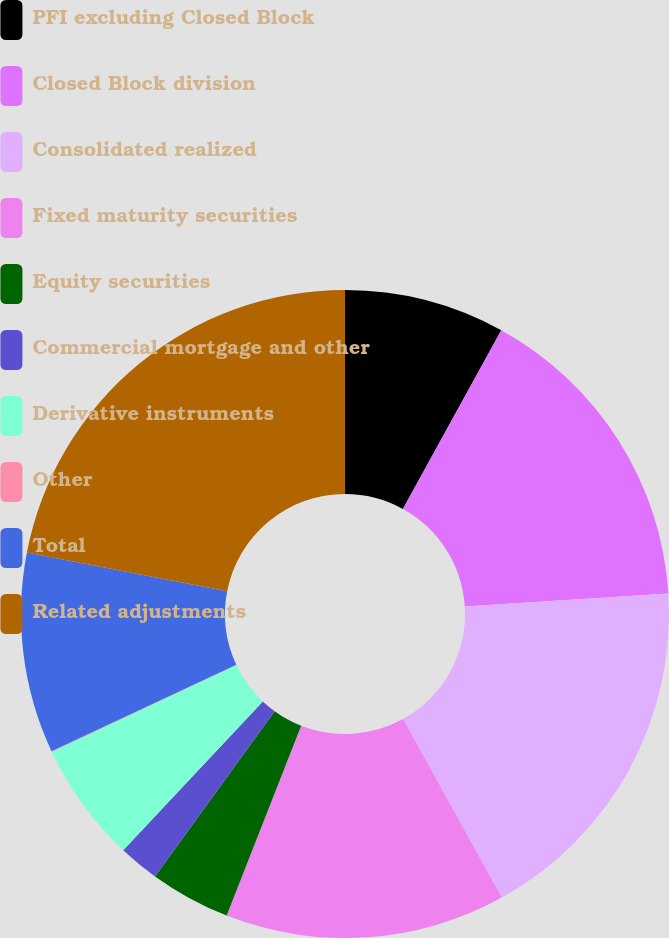Convert chart to OTSL. <chart><loc_0><loc_0><loc_500><loc_500><pie_chart><fcel>PFI excluding Closed Block<fcel>Closed Block division<fcel>Consolidated realized<fcel>Fixed maturity securities<fcel>Equity securities<fcel>Commercial mortgage and other<fcel>Derivative instruments<fcel>Other<fcel>Total<fcel>Related adjustments<nl><fcel>8.01%<fcel>15.98%<fcel>17.97%<fcel>13.99%<fcel>4.02%<fcel>2.03%<fcel>6.01%<fcel>0.03%<fcel>10.0%<fcel>21.96%<nl></chart> 